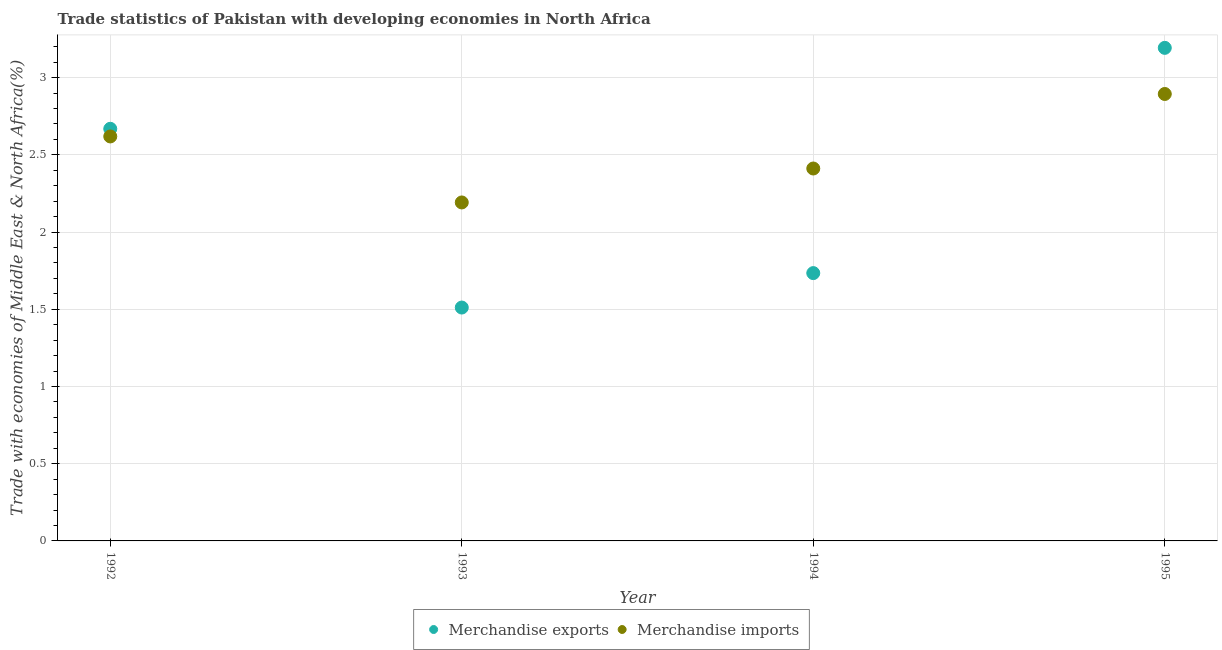What is the merchandise exports in 1995?
Ensure brevity in your answer.  3.19. Across all years, what is the maximum merchandise exports?
Your response must be concise. 3.19. Across all years, what is the minimum merchandise exports?
Your answer should be very brief. 1.51. In which year was the merchandise imports minimum?
Offer a very short reply. 1993. What is the total merchandise exports in the graph?
Ensure brevity in your answer.  9.11. What is the difference between the merchandise exports in 1992 and that in 1994?
Offer a very short reply. 0.93. What is the difference between the merchandise exports in 1994 and the merchandise imports in 1992?
Your response must be concise. -0.88. What is the average merchandise exports per year?
Your response must be concise. 2.28. In the year 1995, what is the difference between the merchandise imports and merchandise exports?
Provide a short and direct response. -0.3. In how many years, is the merchandise exports greater than 1.6 %?
Offer a very short reply. 3. What is the ratio of the merchandise exports in 1993 to that in 1994?
Provide a succinct answer. 0.87. Is the merchandise imports in 1993 less than that in 1995?
Ensure brevity in your answer.  Yes. Is the difference between the merchandise exports in 1993 and 1995 greater than the difference between the merchandise imports in 1993 and 1995?
Keep it short and to the point. No. What is the difference between the highest and the second highest merchandise exports?
Ensure brevity in your answer.  0.52. What is the difference between the highest and the lowest merchandise imports?
Provide a succinct answer. 0.7. Does the merchandise exports monotonically increase over the years?
Your response must be concise. No. How many dotlines are there?
Your answer should be compact. 2. Does the graph contain any zero values?
Provide a short and direct response. No. Does the graph contain grids?
Keep it short and to the point. Yes. How many legend labels are there?
Provide a succinct answer. 2. What is the title of the graph?
Offer a very short reply. Trade statistics of Pakistan with developing economies in North Africa. What is the label or title of the X-axis?
Give a very brief answer. Year. What is the label or title of the Y-axis?
Your answer should be compact. Trade with economies of Middle East & North Africa(%). What is the Trade with economies of Middle East & North Africa(%) of Merchandise exports in 1992?
Offer a very short reply. 2.67. What is the Trade with economies of Middle East & North Africa(%) of Merchandise imports in 1992?
Provide a succinct answer. 2.62. What is the Trade with economies of Middle East & North Africa(%) of Merchandise exports in 1993?
Your answer should be compact. 1.51. What is the Trade with economies of Middle East & North Africa(%) of Merchandise imports in 1993?
Ensure brevity in your answer.  2.19. What is the Trade with economies of Middle East & North Africa(%) in Merchandise exports in 1994?
Offer a very short reply. 1.73. What is the Trade with economies of Middle East & North Africa(%) of Merchandise imports in 1994?
Offer a terse response. 2.41. What is the Trade with economies of Middle East & North Africa(%) in Merchandise exports in 1995?
Ensure brevity in your answer.  3.19. What is the Trade with economies of Middle East & North Africa(%) of Merchandise imports in 1995?
Your answer should be compact. 2.89. Across all years, what is the maximum Trade with economies of Middle East & North Africa(%) of Merchandise exports?
Offer a terse response. 3.19. Across all years, what is the maximum Trade with economies of Middle East & North Africa(%) of Merchandise imports?
Make the answer very short. 2.89. Across all years, what is the minimum Trade with economies of Middle East & North Africa(%) of Merchandise exports?
Offer a very short reply. 1.51. Across all years, what is the minimum Trade with economies of Middle East & North Africa(%) of Merchandise imports?
Ensure brevity in your answer.  2.19. What is the total Trade with economies of Middle East & North Africa(%) of Merchandise exports in the graph?
Offer a terse response. 9.11. What is the total Trade with economies of Middle East & North Africa(%) of Merchandise imports in the graph?
Provide a short and direct response. 10.12. What is the difference between the Trade with economies of Middle East & North Africa(%) in Merchandise exports in 1992 and that in 1993?
Provide a succinct answer. 1.16. What is the difference between the Trade with economies of Middle East & North Africa(%) in Merchandise imports in 1992 and that in 1993?
Offer a terse response. 0.43. What is the difference between the Trade with economies of Middle East & North Africa(%) in Merchandise exports in 1992 and that in 1994?
Ensure brevity in your answer.  0.93. What is the difference between the Trade with economies of Middle East & North Africa(%) of Merchandise imports in 1992 and that in 1994?
Ensure brevity in your answer.  0.21. What is the difference between the Trade with economies of Middle East & North Africa(%) in Merchandise exports in 1992 and that in 1995?
Provide a short and direct response. -0.52. What is the difference between the Trade with economies of Middle East & North Africa(%) in Merchandise imports in 1992 and that in 1995?
Ensure brevity in your answer.  -0.28. What is the difference between the Trade with economies of Middle East & North Africa(%) of Merchandise exports in 1993 and that in 1994?
Make the answer very short. -0.22. What is the difference between the Trade with economies of Middle East & North Africa(%) of Merchandise imports in 1993 and that in 1994?
Keep it short and to the point. -0.22. What is the difference between the Trade with economies of Middle East & North Africa(%) in Merchandise exports in 1993 and that in 1995?
Offer a very short reply. -1.68. What is the difference between the Trade with economies of Middle East & North Africa(%) of Merchandise imports in 1993 and that in 1995?
Offer a very short reply. -0.7. What is the difference between the Trade with economies of Middle East & North Africa(%) of Merchandise exports in 1994 and that in 1995?
Your answer should be compact. -1.46. What is the difference between the Trade with economies of Middle East & North Africa(%) of Merchandise imports in 1994 and that in 1995?
Provide a short and direct response. -0.48. What is the difference between the Trade with economies of Middle East & North Africa(%) in Merchandise exports in 1992 and the Trade with economies of Middle East & North Africa(%) in Merchandise imports in 1993?
Make the answer very short. 0.48. What is the difference between the Trade with economies of Middle East & North Africa(%) in Merchandise exports in 1992 and the Trade with economies of Middle East & North Africa(%) in Merchandise imports in 1994?
Provide a succinct answer. 0.26. What is the difference between the Trade with economies of Middle East & North Africa(%) of Merchandise exports in 1992 and the Trade with economies of Middle East & North Africa(%) of Merchandise imports in 1995?
Provide a short and direct response. -0.23. What is the difference between the Trade with economies of Middle East & North Africa(%) of Merchandise exports in 1993 and the Trade with economies of Middle East & North Africa(%) of Merchandise imports in 1994?
Your answer should be very brief. -0.9. What is the difference between the Trade with economies of Middle East & North Africa(%) in Merchandise exports in 1993 and the Trade with economies of Middle East & North Africa(%) in Merchandise imports in 1995?
Ensure brevity in your answer.  -1.38. What is the difference between the Trade with economies of Middle East & North Africa(%) in Merchandise exports in 1994 and the Trade with economies of Middle East & North Africa(%) in Merchandise imports in 1995?
Your response must be concise. -1.16. What is the average Trade with economies of Middle East & North Africa(%) of Merchandise exports per year?
Provide a succinct answer. 2.28. What is the average Trade with economies of Middle East & North Africa(%) in Merchandise imports per year?
Give a very brief answer. 2.53. In the year 1992, what is the difference between the Trade with economies of Middle East & North Africa(%) of Merchandise exports and Trade with economies of Middle East & North Africa(%) of Merchandise imports?
Your answer should be compact. 0.05. In the year 1993, what is the difference between the Trade with economies of Middle East & North Africa(%) in Merchandise exports and Trade with economies of Middle East & North Africa(%) in Merchandise imports?
Offer a very short reply. -0.68. In the year 1994, what is the difference between the Trade with economies of Middle East & North Africa(%) of Merchandise exports and Trade with economies of Middle East & North Africa(%) of Merchandise imports?
Keep it short and to the point. -0.68. In the year 1995, what is the difference between the Trade with economies of Middle East & North Africa(%) in Merchandise exports and Trade with economies of Middle East & North Africa(%) in Merchandise imports?
Offer a very short reply. 0.3. What is the ratio of the Trade with economies of Middle East & North Africa(%) in Merchandise exports in 1992 to that in 1993?
Keep it short and to the point. 1.77. What is the ratio of the Trade with economies of Middle East & North Africa(%) in Merchandise imports in 1992 to that in 1993?
Offer a terse response. 1.2. What is the ratio of the Trade with economies of Middle East & North Africa(%) in Merchandise exports in 1992 to that in 1994?
Keep it short and to the point. 1.54. What is the ratio of the Trade with economies of Middle East & North Africa(%) in Merchandise imports in 1992 to that in 1994?
Make the answer very short. 1.09. What is the ratio of the Trade with economies of Middle East & North Africa(%) in Merchandise exports in 1992 to that in 1995?
Your answer should be compact. 0.84. What is the ratio of the Trade with economies of Middle East & North Africa(%) of Merchandise imports in 1992 to that in 1995?
Provide a succinct answer. 0.91. What is the ratio of the Trade with economies of Middle East & North Africa(%) in Merchandise exports in 1993 to that in 1994?
Ensure brevity in your answer.  0.87. What is the ratio of the Trade with economies of Middle East & North Africa(%) in Merchandise imports in 1993 to that in 1994?
Give a very brief answer. 0.91. What is the ratio of the Trade with economies of Middle East & North Africa(%) of Merchandise exports in 1993 to that in 1995?
Offer a very short reply. 0.47. What is the ratio of the Trade with economies of Middle East & North Africa(%) of Merchandise imports in 1993 to that in 1995?
Your answer should be very brief. 0.76. What is the ratio of the Trade with economies of Middle East & North Africa(%) of Merchandise exports in 1994 to that in 1995?
Your response must be concise. 0.54. What is the ratio of the Trade with economies of Middle East & North Africa(%) of Merchandise imports in 1994 to that in 1995?
Provide a succinct answer. 0.83. What is the difference between the highest and the second highest Trade with economies of Middle East & North Africa(%) in Merchandise exports?
Your answer should be very brief. 0.52. What is the difference between the highest and the second highest Trade with economies of Middle East & North Africa(%) of Merchandise imports?
Provide a succinct answer. 0.28. What is the difference between the highest and the lowest Trade with economies of Middle East & North Africa(%) of Merchandise exports?
Ensure brevity in your answer.  1.68. What is the difference between the highest and the lowest Trade with economies of Middle East & North Africa(%) in Merchandise imports?
Give a very brief answer. 0.7. 